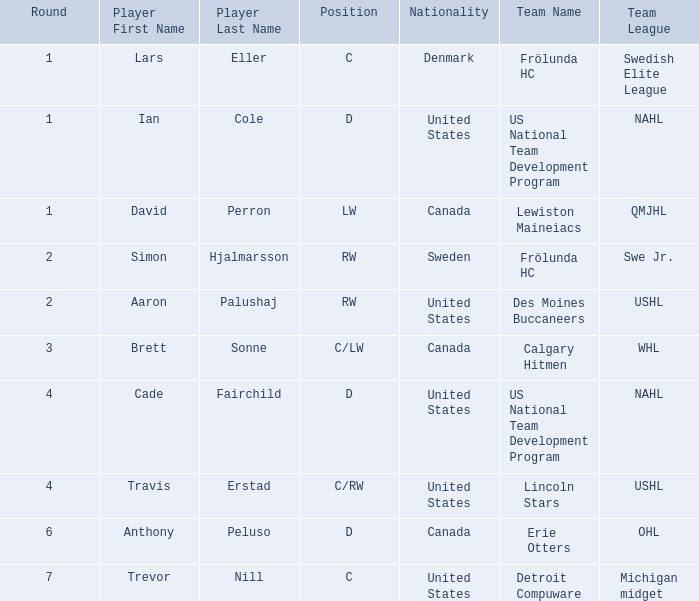Which college/junior/club team (league) did Brett Sonne play in? Calgary Hitmen ( WHL ). 